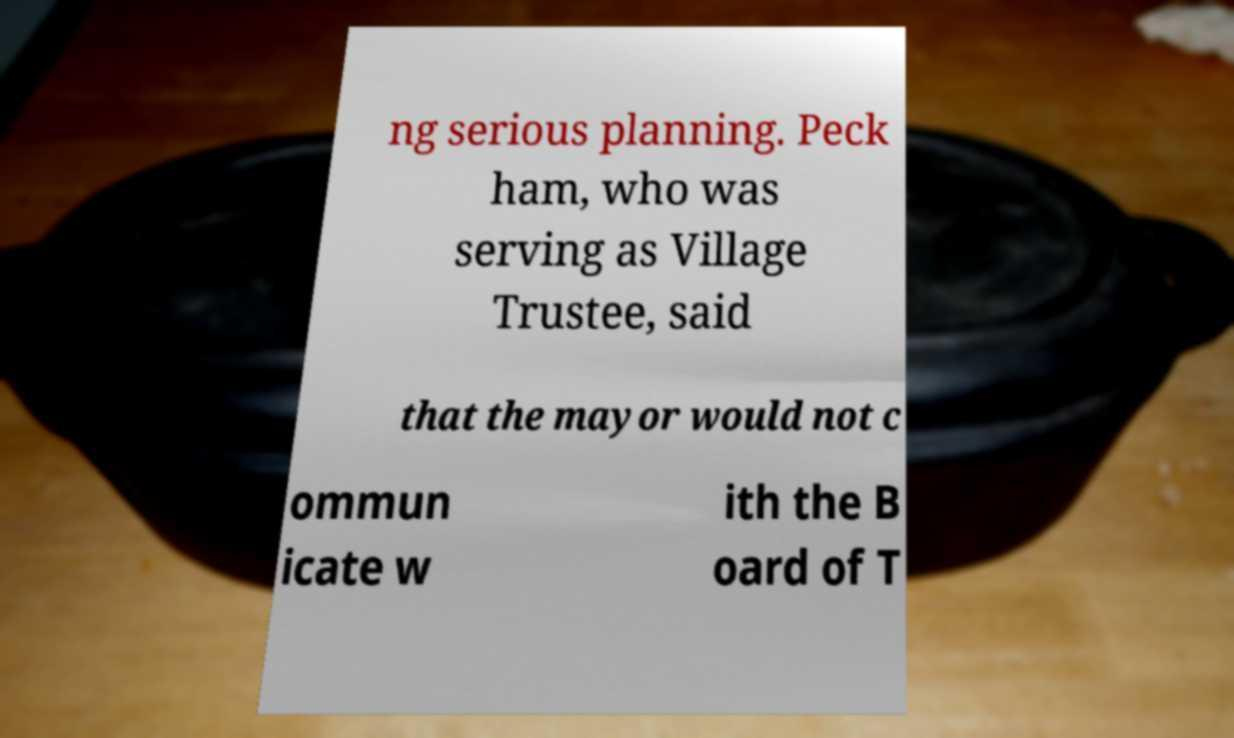Can you read and provide the text displayed in the image?This photo seems to have some interesting text. Can you extract and type it out for me? ng serious planning. Peck ham, who was serving as Village Trustee, said that the mayor would not c ommun icate w ith the B oard of T 